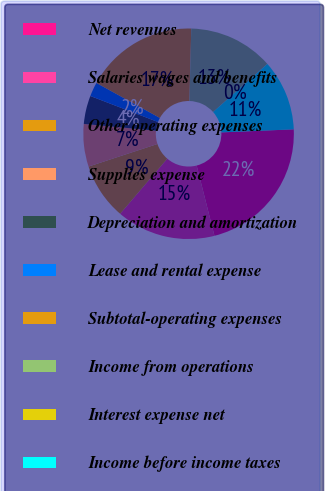<chart> <loc_0><loc_0><loc_500><loc_500><pie_chart><fcel>Net revenues<fcel>Salaries wages and benefits<fcel>Other operating expenses<fcel>Supplies expense<fcel>Depreciation and amortization<fcel>Lease and rental expense<fcel>Subtotal-operating expenses<fcel>Income from operations<fcel>Interest expense net<fcel>Income before income taxes<nl><fcel>21.72%<fcel>15.21%<fcel>8.7%<fcel>6.53%<fcel>4.35%<fcel>2.18%<fcel>17.38%<fcel>13.04%<fcel>0.01%<fcel>10.87%<nl></chart> 